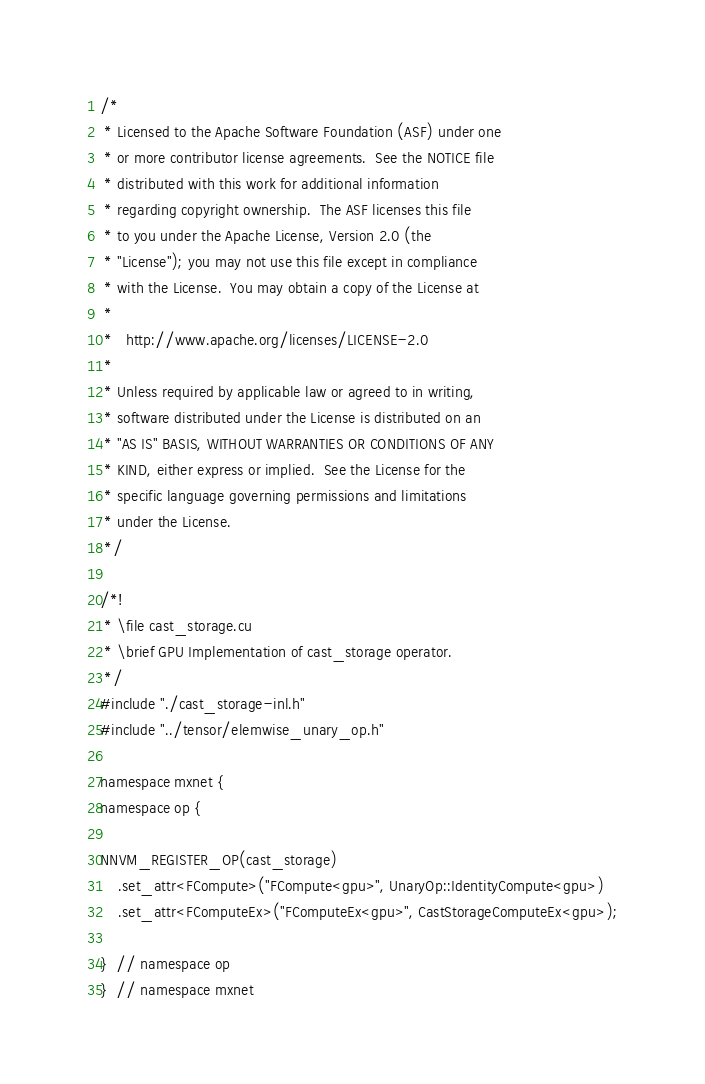<code> <loc_0><loc_0><loc_500><loc_500><_Cuda_>/*
 * Licensed to the Apache Software Foundation (ASF) under one
 * or more contributor license agreements.  See the NOTICE file
 * distributed with this work for additional information
 * regarding copyright ownership.  The ASF licenses this file
 * to you under the Apache License, Version 2.0 (the
 * "License"); you may not use this file except in compliance
 * with the License.  You may obtain a copy of the License at
 *
 *   http://www.apache.org/licenses/LICENSE-2.0
 *
 * Unless required by applicable law or agreed to in writing,
 * software distributed under the License is distributed on an
 * "AS IS" BASIS, WITHOUT WARRANTIES OR CONDITIONS OF ANY
 * KIND, either express or implied.  See the License for the
 * specific language governing permissions and limitations
 * under the License.
 */

/*!
 * \file cast_storage.cu
 * \brief GPU Implementation of cast_storage operator.
 */
#include "./cast_storage-inl.h"
#include "../tensor/elemwise_unary_op.h"

namespace mxnet {
namespace op {

NNVM_REGISTER_OP(cast_storage)
    .set_attr<FCompute>("FCompute<gpu>", UnaryOp::IdentityCompute<gpu>)
    .set_attr<FComputeEx>("FComputeEx<gpu>", CastStorageComputeEx<gpu>);

}  // namespace op
}  // namespace mxnet
</code> 